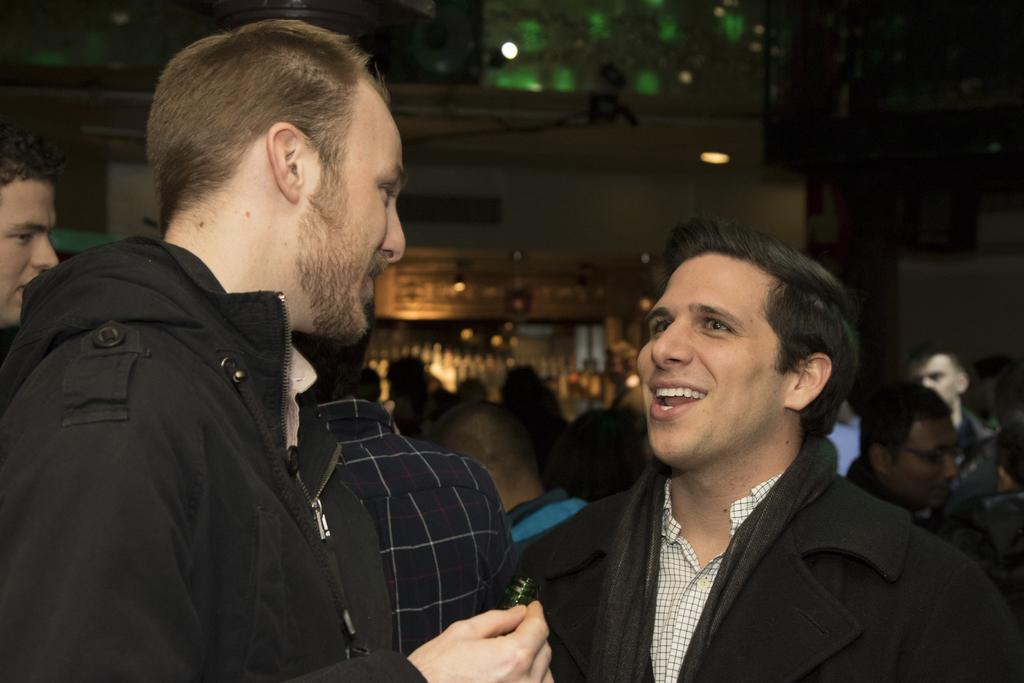What is the position of the man on the left side of the image? The man on the left side of the image is on the left side. What is the man on the left side wearing? The man on the left side is wearing a black coat. What is the man on the left side doing? The man on the left side is looking at another person. What is the position of the man on the right side of the image? The man on the right side of the image is on the right side. What is the man on the right side doing? The man on the right side is talking with the man on the left side. What is the facial expression of the man on the right side? The man on the right side is smiling. What type of bulb is hanging from the ceiling in the image? There is no mention of a bulb or a ceiling in the image, so it cannot be determined if there is a bulb present. How many girls are visible in the image? There is no mention of a girl or any female subjects in the image, so it cannot be determined if there are any girls present. 